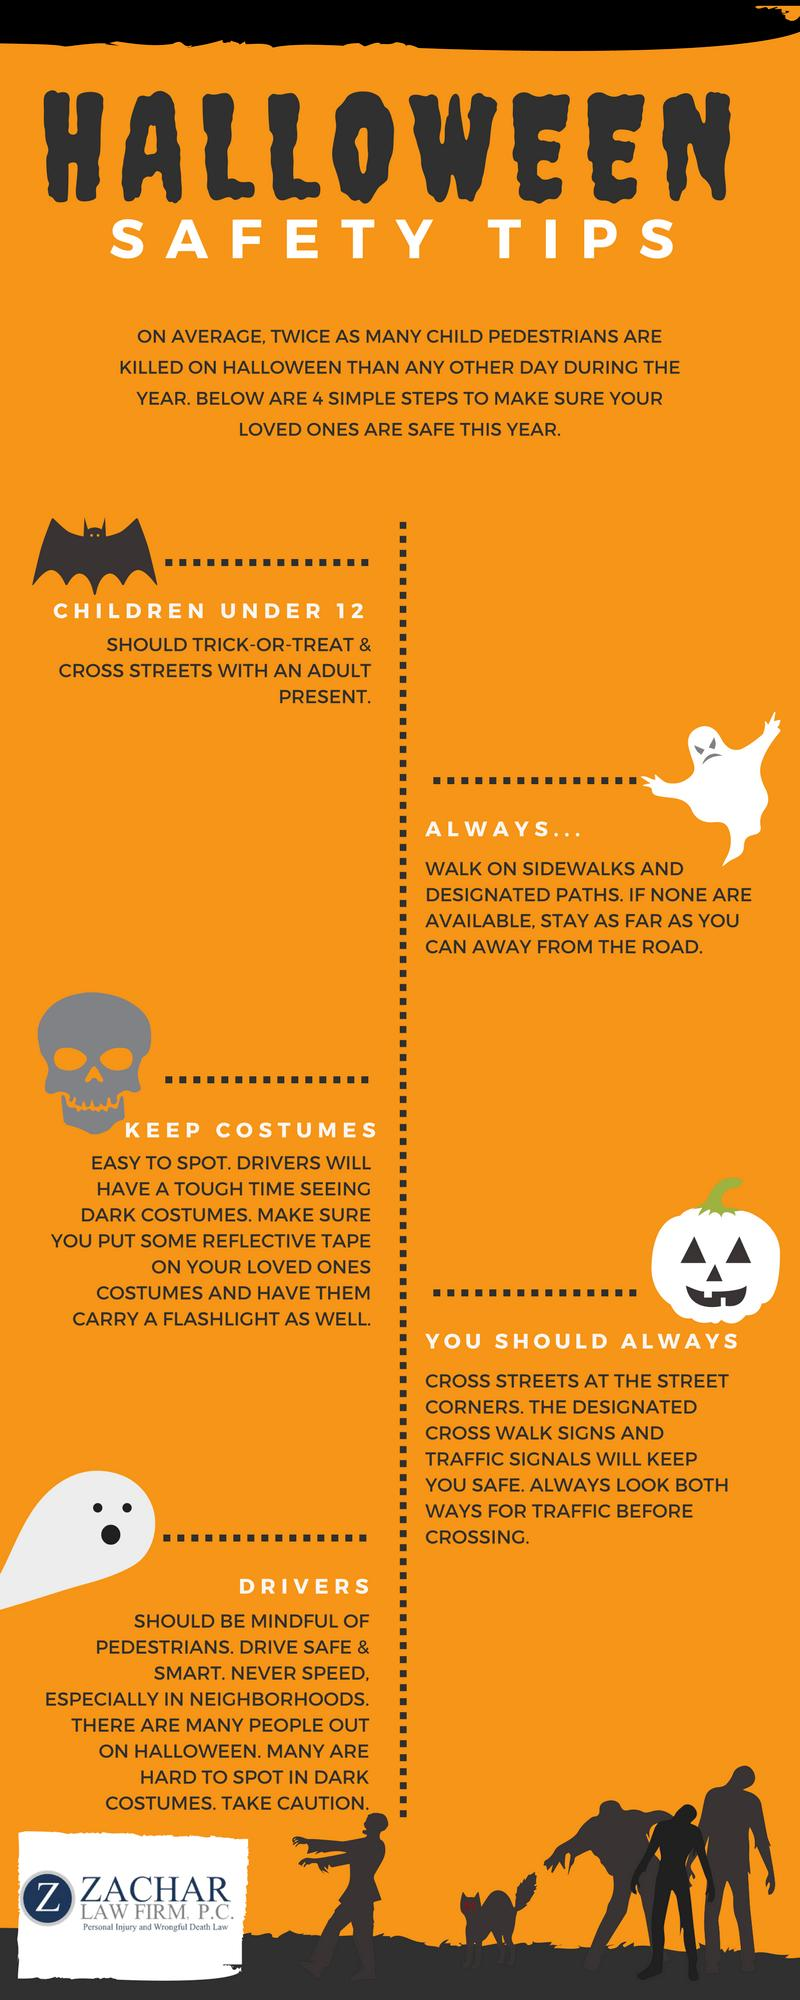Identify some key points in this picture. Drivers are responsible for ensuring the safety of pedestrians while operating a motor vehicle. It is possible to make costumes more visible by using reflective tape. Trick-or-treating is a traditional Halloween custom where individuals dress up in costumes and go door-to-door in their neighborhoods, typically on October 31st, to receive treats such as candy or small toys. 